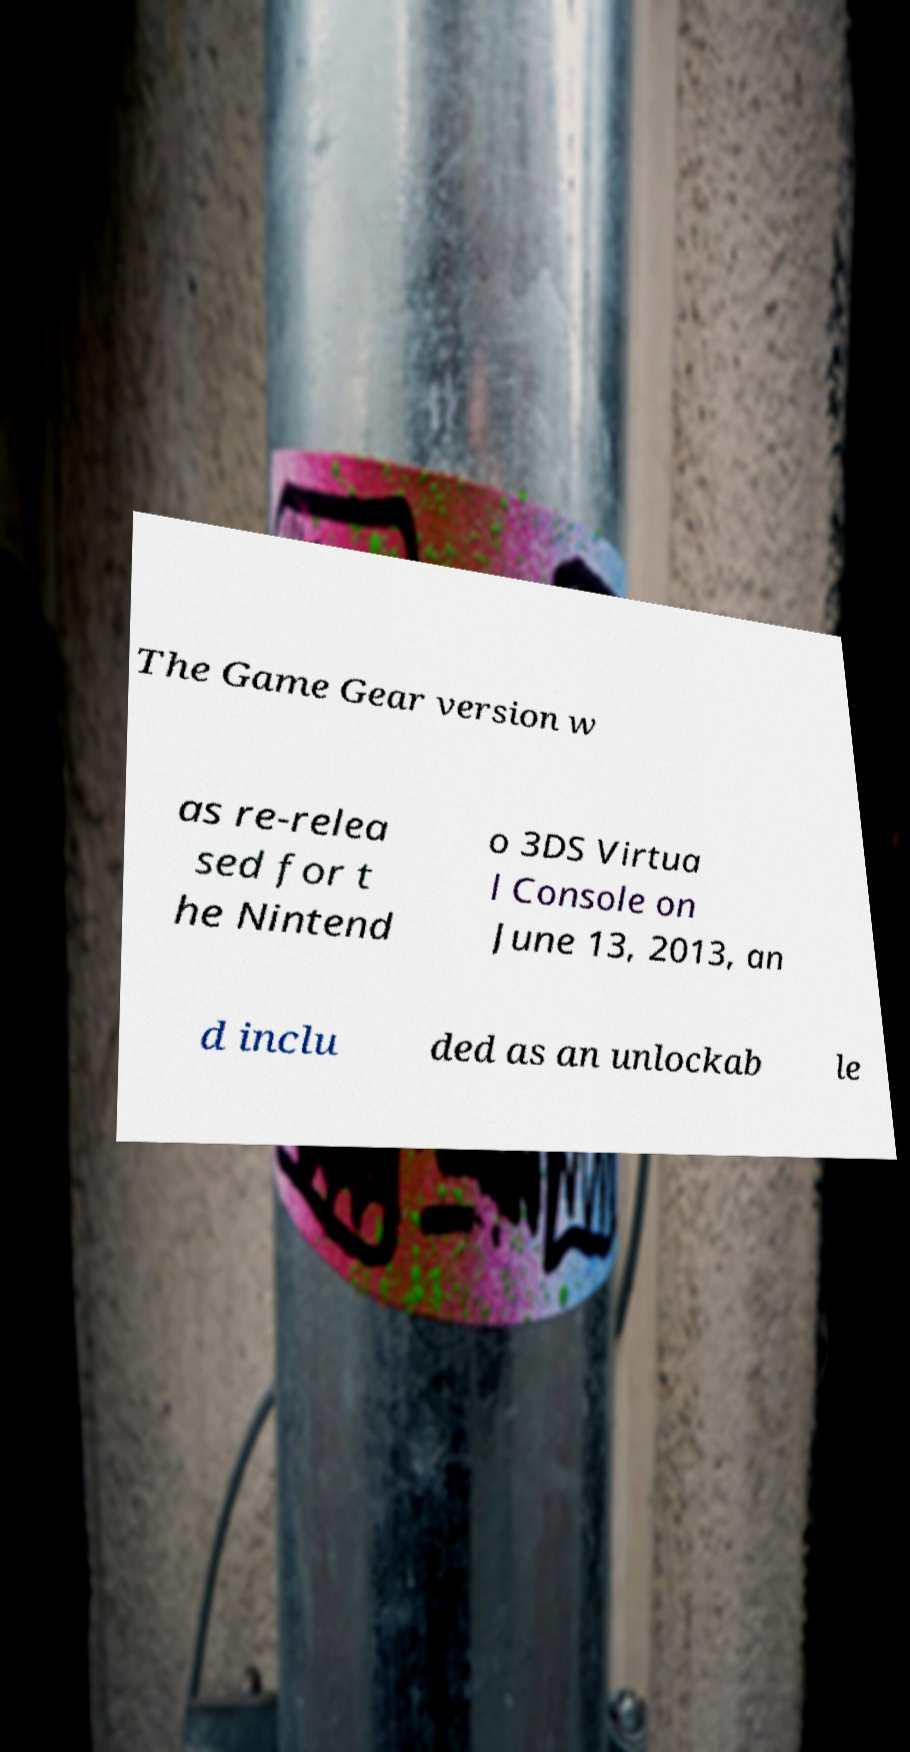What messages or text are displayed in this image? I need them in a readable, typed format. The Game Gear version w as re-relea sed for t he Nintend o 3DS Virtua l Console on June 13, 2013, an d inclu ded as an unlockab le 